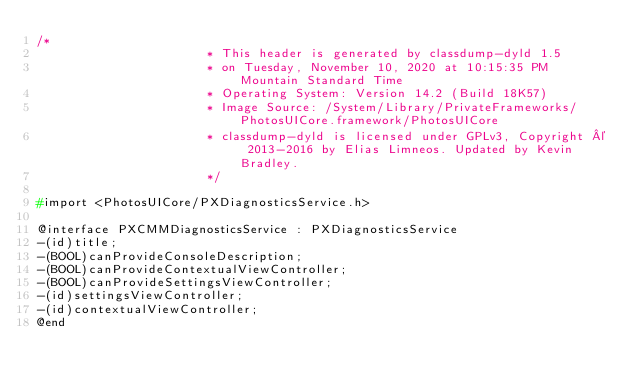Convert code to text. <code><loc_0><loc_0><loc_500><loc_500><_C_>/*
                       * This header is generated by classdump-dyld 1.5
                       * on Tuesday, November 10, 2020 at 10:15:35 PM Mountain Standard Time
                       * Operating System: Version 14.2 (Build 18K57)
                       * Image Source: /System/Library/PrivateFrameworks/PhotosUICore.framework/PhotosUICore
                       * classdump-dyld is licensed under GPLv3, Copyright © 2013-2016 by Elias Limneos. Updated by Kevin Bradley.
                       */

#import <PhotosUICore/PXDiagnosticsService.h>

@interface PXCMMDiagnosticsService : PXDiagnosticsService
-(id)title;
-(BOOL)canProvideConsoleDescription;
-(BOOL)canProvideContextualViewController;
-(BOOL)canProvideSettingsViewController;
-(id)settingsViewController;
-(id)contextualViewController;
@end

</code> 